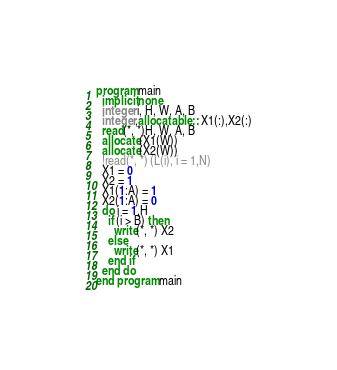<code> <loc_0><loc_0><loc_500><loc_500><_FORTRAN_>program main
  implicit none
  integer i, H, W, A, B
  integer,allocatable :: X1(:),X2(:)
  read(*, *)H, W, A, B
  allocate(X1(W))
  allocate(X2(W))
  !read(*, *) (L(i), i = 1,N)
  X1 = 0
  X2 = 1
  X1(1:A) = 1
  X2(1:A) = 0
  do i = 1,H
    if (i > B) then
      write(*, *) X2
    else
      write(*, *) X1
    end if
  end do
end program main
</code> 